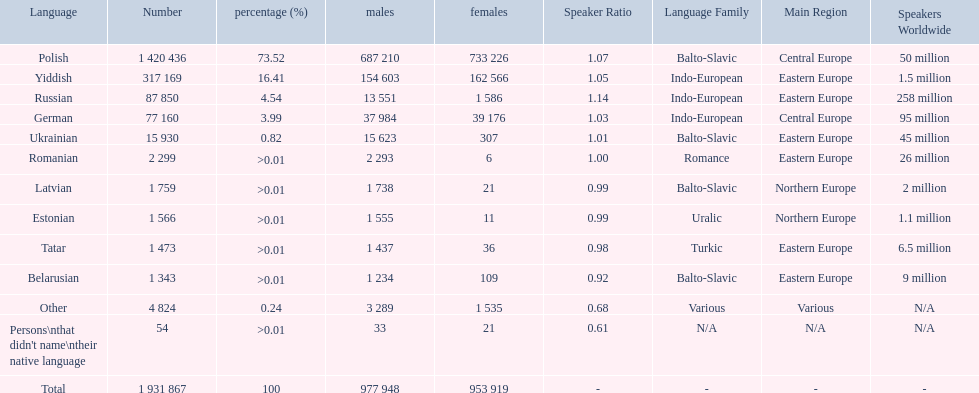Which languages had percentages of >0.01? Romanian, Latvian, Estonian, Tatar, Belarusian. What was the top language? Romanian. 